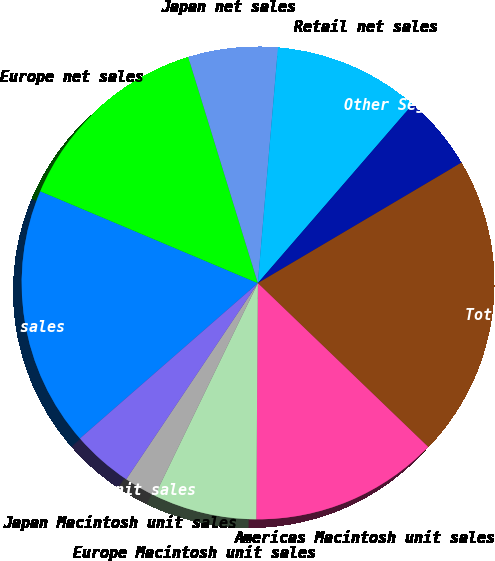Convert chart to OTSL. <chart><loc_0><loc_0><loc_500><loc_500><pie_chart><fcel>Americas net sales<fcel>Europe net sales<fcel>Japan net sales<fcel>Retail net sales<fcel>Other Segments net sales (a)<fcel>Total net sales<fcel>Americas Macintosh unit sales<fcel>Europe Macintosh unit sales<fcel>Japan Macintosh unit sales<fcel>Retail Macintosh unit sales<nl><fcel>17.78%<fcel>13.89%<fcel>6.11%<fcel>10.0%<fcel>5.14%<fcel>20.69%<fcel>12.92%<fcel>7.08%<fcel>2.22%<fcel>4.17%<nl></chart> 